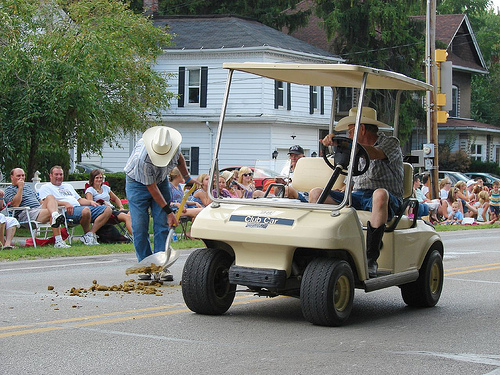<image>
Is there a guy on the car? Yes. Looking at the image, I can see the guy is positioned on top of the car, with the car providing support. Is there a shovel under the hat? Yes. The shovel is positioned underneath the hat, with the hat above it in the vertical space. 